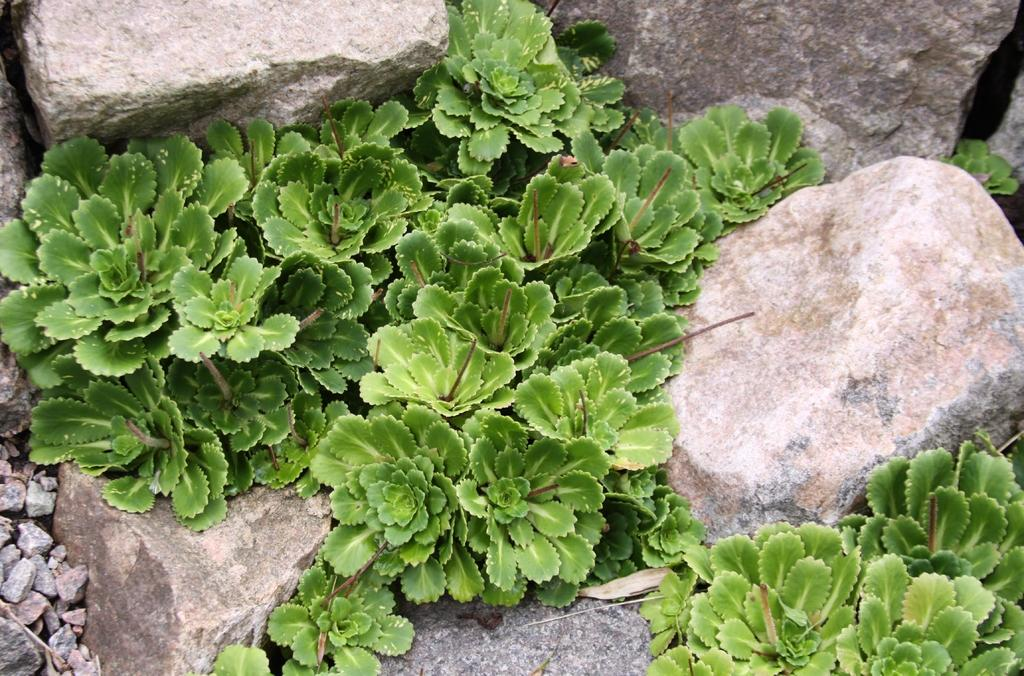What type of living organisms can be seen in the image? Plants can be seen in the image. What other objects are present in the image besides the plants? There are stones in the image. What type of oatmeal is being prepared in the image? There is no oatmeal present in the image; it only contains plants and stones. 